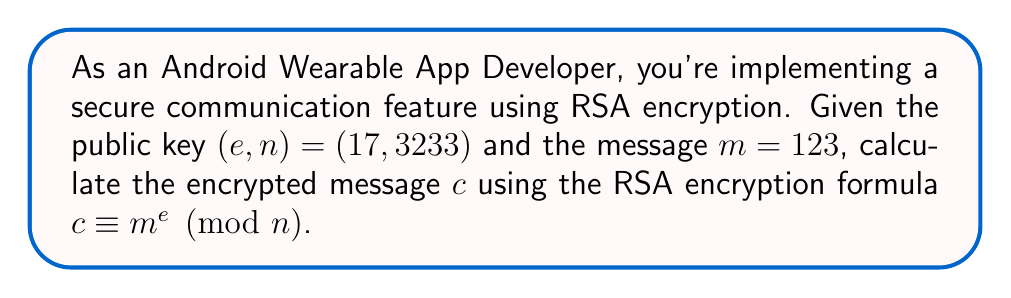What is the answer to this math problem? To calculate the encrypted message, we need to use modular exponentiation. Let's break it down step-by-step:

1) The RSA encryption formula is:
   $c \equiv m^e \pmod{n}$

2) We have:
   $m = 123$
   $e = 17$
   $n = 3233$

3) We need to calculate $123^{17} \pmod{3233}$

4) To efficiently compute this, we can use the square-and-multiply algorithm:

   $123^2 \equiv 15129 \equiv 2197 \pmod{3233}$
   $123^4 \equiv 2197^2 \equiv 1369 \pmod{3233}$
   $123^8 \equiv 1369^2 \equiv 1874561 \equiv 855 \pmod{3233}$
   $123^{16} \equiv 855^2 \equiv 731025 \equiv 2401 \pmod{3233}$

5) Now, $123^{17} = 123 \cdot 123^{16}$

   $123 \cdot 2401 \equiv 295323 \equiv 855 \pmod{3233}$

Therefore, the encrypted message $c$ is 855.
Answer: $855$ 